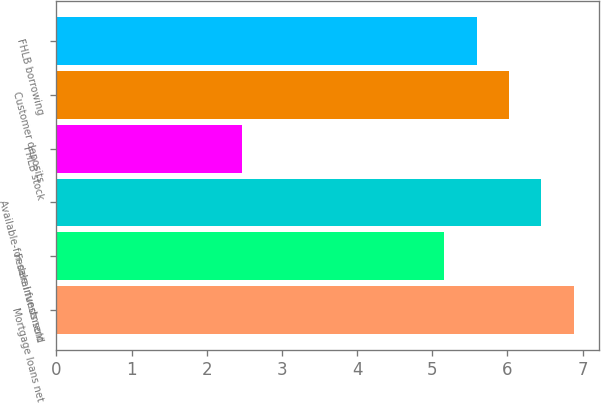Convert chart. <chart><loc_0><loc_0><loc_500><loc_500><bar_chart><fcel>Mortgage loans net<fcel>Federal funds sold<fcel>Available-for-sale investment<fcel>FHLB stock<fcel>Customer deposits<fcel>FHLB borrowing<nl><fcel>6.88<fcel>5.16<fcel>6.45<fcel>2.47<fcel>6.02<fcel>5.59<nl></chart> 